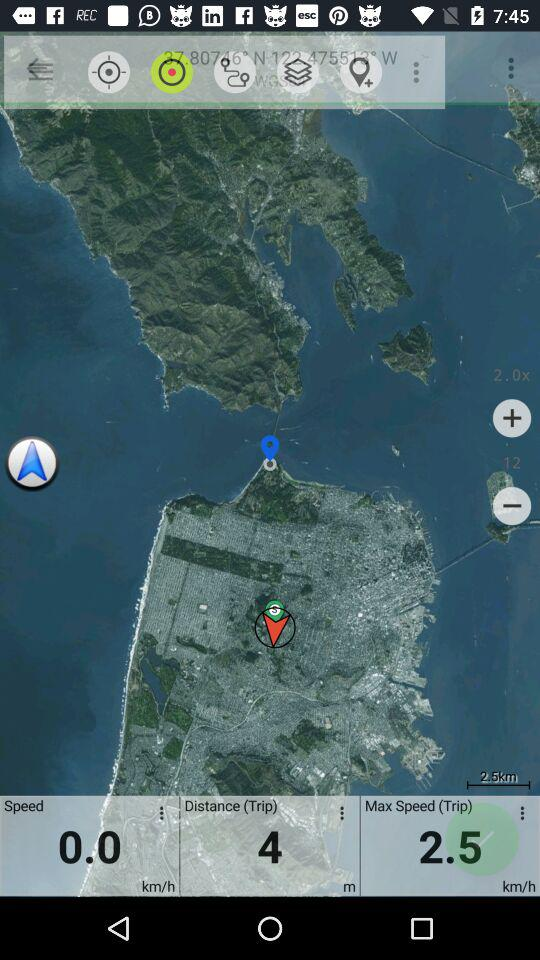What's the maximum speed? The maximum speed is 2.5 km/h. 